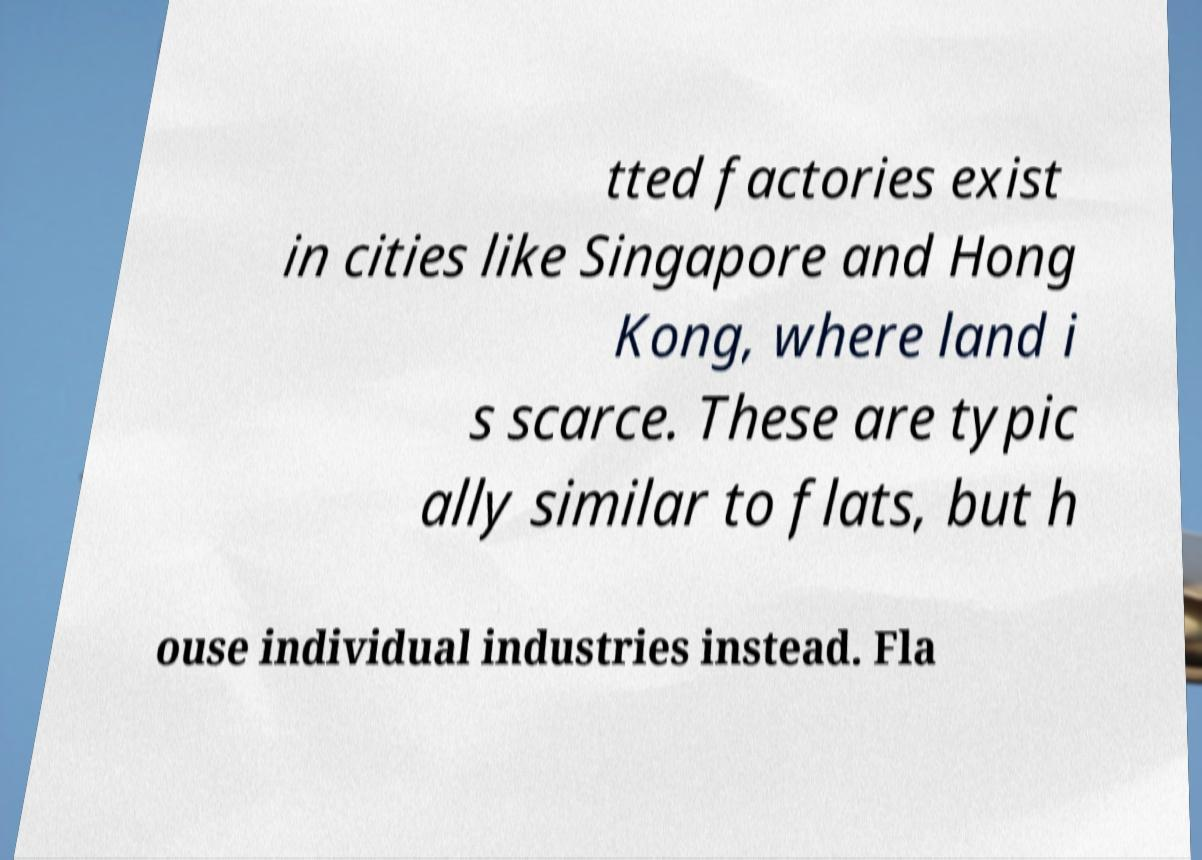I need the written content from this picture converted into text. Can you do that? tted factories exist in cities like Singapore and Hong Kong, where land i s scarce. These are typic ally similar to flats, but h ouse individual industries instead. Fla 